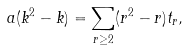Convert formula to latex. <formula><loc_0><loc_0><loc_500><loc_500>a ( k ^ { 2 } - k ) = \sum _ { r \geq 2 } ( r ^ { 2 } - r ) t _ { r } ,</formula> 